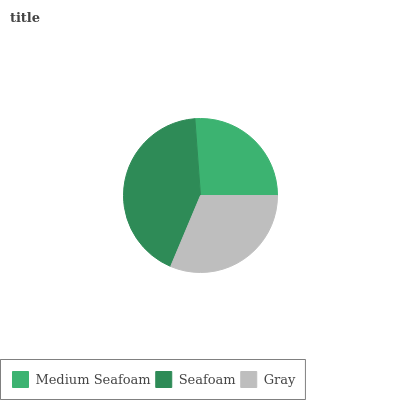Is Medium Seafoam the minimum?
Answer yes or no. Yes. Is Seafoam the maximum?
Answer yes or no. Yes. Is Gray the minimum?
Answer yes or no. No. Is Gray the maximum?
Answer yes or no. No. Is Seafoam greater than Gray?
Answer yes or no. Yes. Is Gray less than Seafoam?
Answer yes or no. Yes. Is Gray greater than Seafoam?
Answer yes or no. No. Is Seafoam less than Gray?
Answer yes or no. No. Is Gray the high median?
Answer yes or no. Yes. Is Gray the low median?
Answer yes or no. Yes. Is Seafoam the high median?
Answer yes or no. No. Is Seafoam the low median?
Answer yes or no. No. 